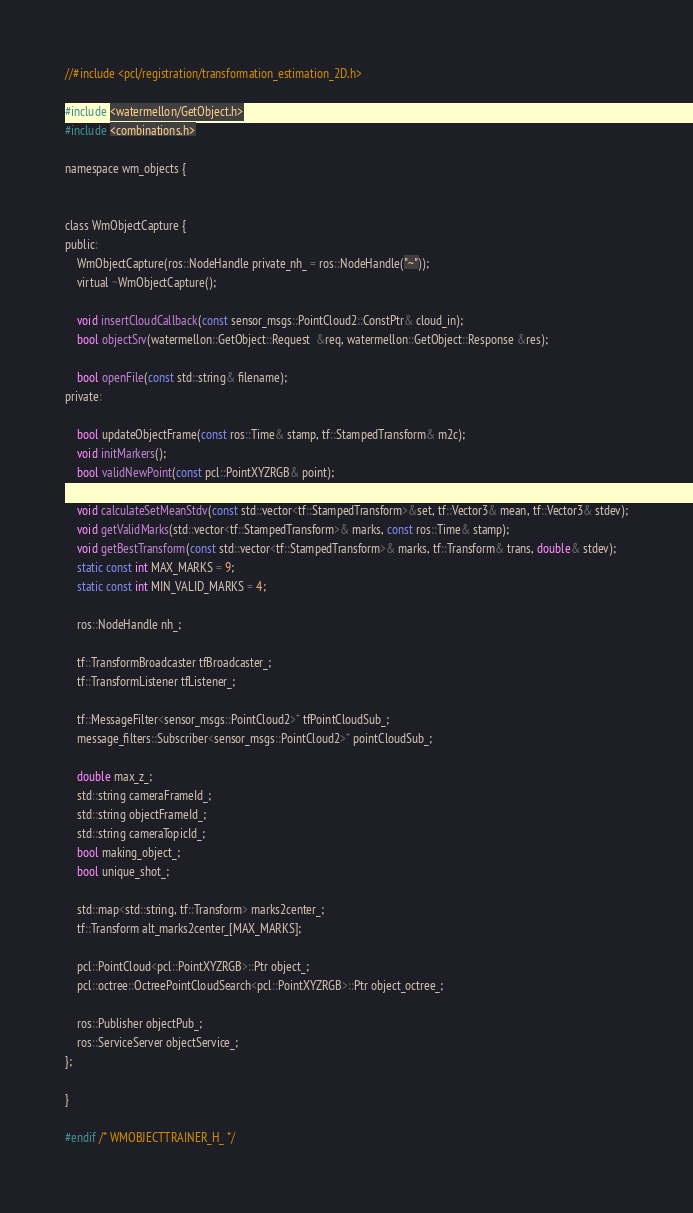Convert code to text. <code><loc_0><loc_0><loc_500><loc_500><_C_>
//#include <pcl/registration/transformation_estimation_2D.h>

#include <watermellon/GetObject.h>
#include <combinations.h>

namespace wm_objects {


class WmObjectCapture {
public:
	WmObjectCapture(ros::NodeHandle private_nh_ = ros::NodeHandle("~"));
	virtual ~WmObjectCapture();

	void insertCloudCallback(const sensor_msgs::PointCloud2::ConstPtr& cloud_in);
	bool objectSrv(watermellon::GetObject::Request  &req, watermellon::GetObject::Response &res);

	bool openFile(const std::string& filename);
private:

	bool updateObjectFrame(const ros::Time& stamp, tf::StampedTransform& m2c);
	void initMarkers();
	bool validNewPoint(const pcl::PointXYZRGB& point);

	void calculateSetMeanStdv(const std::vector<tf::StampedTransform>&set, tf::Vector3& mean, tf::Vector3& stdev);
	void getValidMarks(std::vector<tf::StampedTransform>& marks, const ros::Time& stamp);
	void getBestTransform(const std::vector<tf::StampedTransform>& marks, tf::Transform& trans, double& stdev);
	static const int MAX_MARKS = 9;
	static const int MIN_VALID_MARKS = 4;

	ros::NodeHandle nh_;

	tf::TransformBroadcaster tfBroadcaster_;
	tf::TransformListener tfListener_;

	tf::MessageFilter<sensor_msgs::PointCloud2>* tfPointCloudSub_;
	message_filters::Subscriber<sensor_msgs::PointCloud2>* pointCloudSub_;

	double max_z_;
	std::string cameraFrameId_;
	std::string objectFrameId_;
	std::string cameraTopicId_;
	bool making_object_;
	bool unique_shot_;

	std::map<std::string, tf::Transform> marks2center_;
	tf::Transform alt_marks2center_[MAX_MARKS];

	pcl::PointCloud<pcl::PointXYZRGB>::Ptr object_;
	pcl::octree::OctreePointCloudSearch<pcl::PointXYZRGB>::Ptr object_octree_;

	ros::Publisher objectPub_;
	ros::ServiceServer objectService_;
};

}

#endif /* WMOBJECTTRAINER_H_ */
</code> 